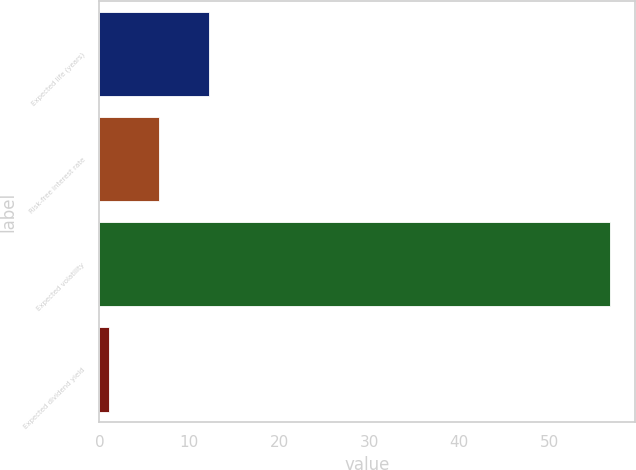Convert chart to OTSL. <chart><loc_0><loc_0><loc_500><loc_500><bar_chart><fcel>Expected life (years)<fcel>Risk-free interest rate<fcel>Expected volatility<fcel>Expected dividend yield<nl><fcel>12.22<fcel>6.66<fcel>56.7<fcel>1.1<nl></chart> 